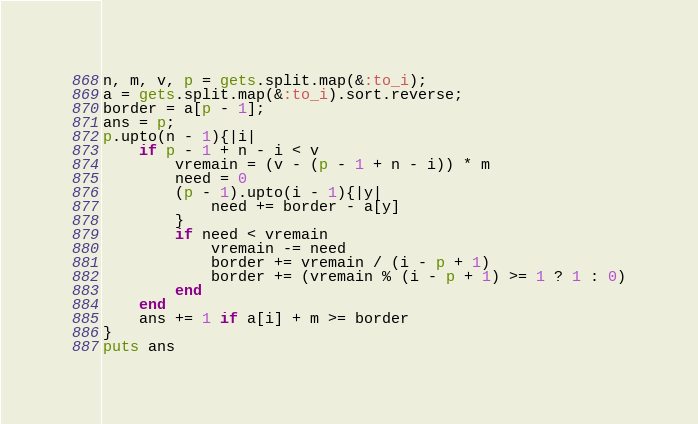<code> <loc_0><loc_0><loc_500><loc_500><_Ruby_>n, m, v, p = gets.split.map(&:to_i);
a = gets.split.map(&:to_i).sort.reverse;
border = a[p - 1];
ans = p;
p.upto(n - 1){|i|
	if p - 1 + n - i < v
		vremain = (v - (p - 1 + n - i)) * m
		need = 0
		(p - 1).upto(i - 1){|y|
			need += border - a[y]
		}
		if need < vremain
			vremain -= need
			border += vremain / (i - p + 1)
			border += (vremain % (i - p + 1) >= 1 ? 1 : 0)
		end
	end
	ans += 1 if a[i] + m >= border
}
puts ans</code> 